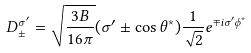Convert formula to latex. <formula><loc_0><loc_0><loc_500><loc_500>D _ { \pm } ^ { \sigma ^ { \prime } } = \sqrt { \frac { 3 B } { 1 6 \pi } } ( \sigma ^ { \prime } \pm \cos \theta ^ { * } ) \frac { 1 } { \sqrt { 2 } } e ^ { \mp i \sigma ^ { \prime } \phi ^ { * } }</formula> 